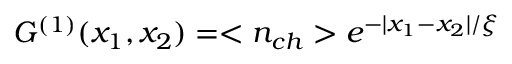<formula> <loc_0><loc_0><loc_500><loc_500>G ^ { ( 1 ) } ( x _ { 1 } , x _ { 2 } ) = < n _ { c h } > e ^ { - | x _ { 1 } - x _ { 2 } | / \xi }</formula> 